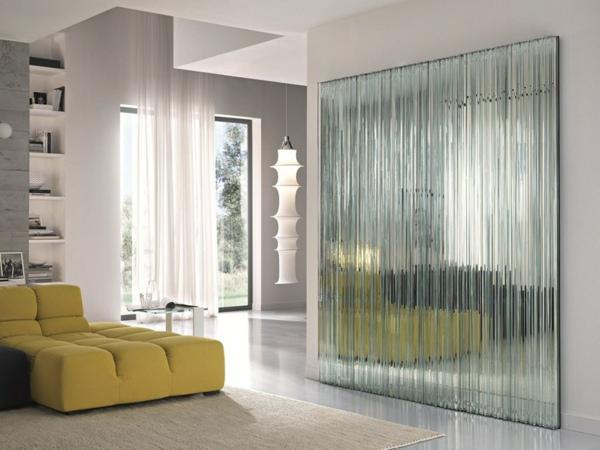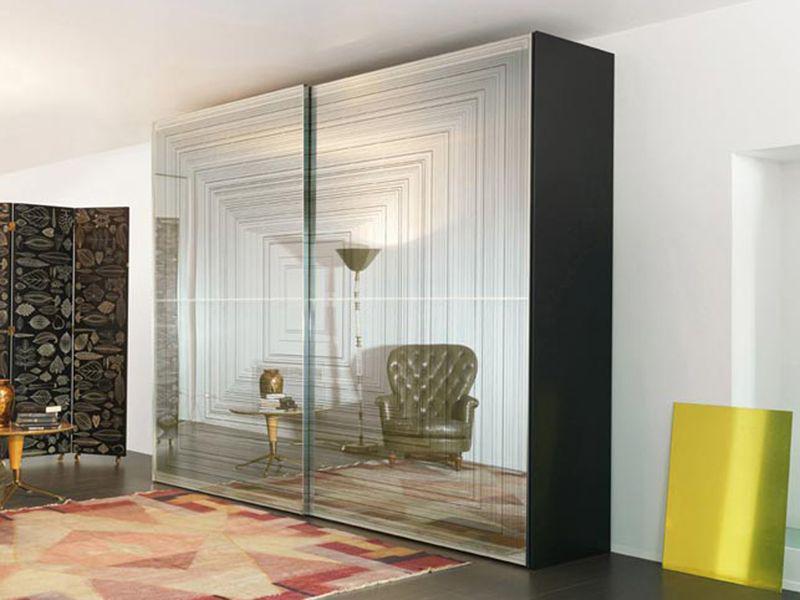The first image is the image on the left, the second image is the image on the right. Assess this claim about the two images: "One closet's doors has a photographic image design.". Correct or not? Answer yes or no. No. 